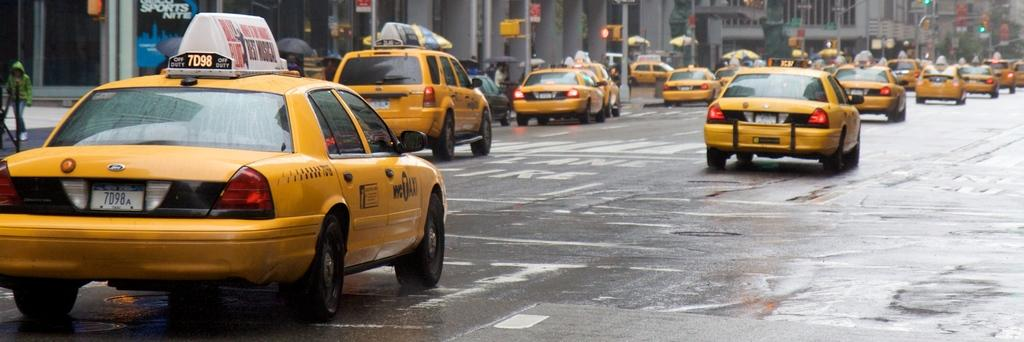What type of vehicles can be seen moving on the road in the image? There are many taxis moving on the road in the image. What can be seen in the background behind the taxis? There are buildings visible behind the taxis. Where are the traffic signal poles located in the image? The traffic signal poles are on the left side of the image. What type of texture can be seen on the worm in the image? There is no worm present in the image, so it is not possible to determine its texture. 